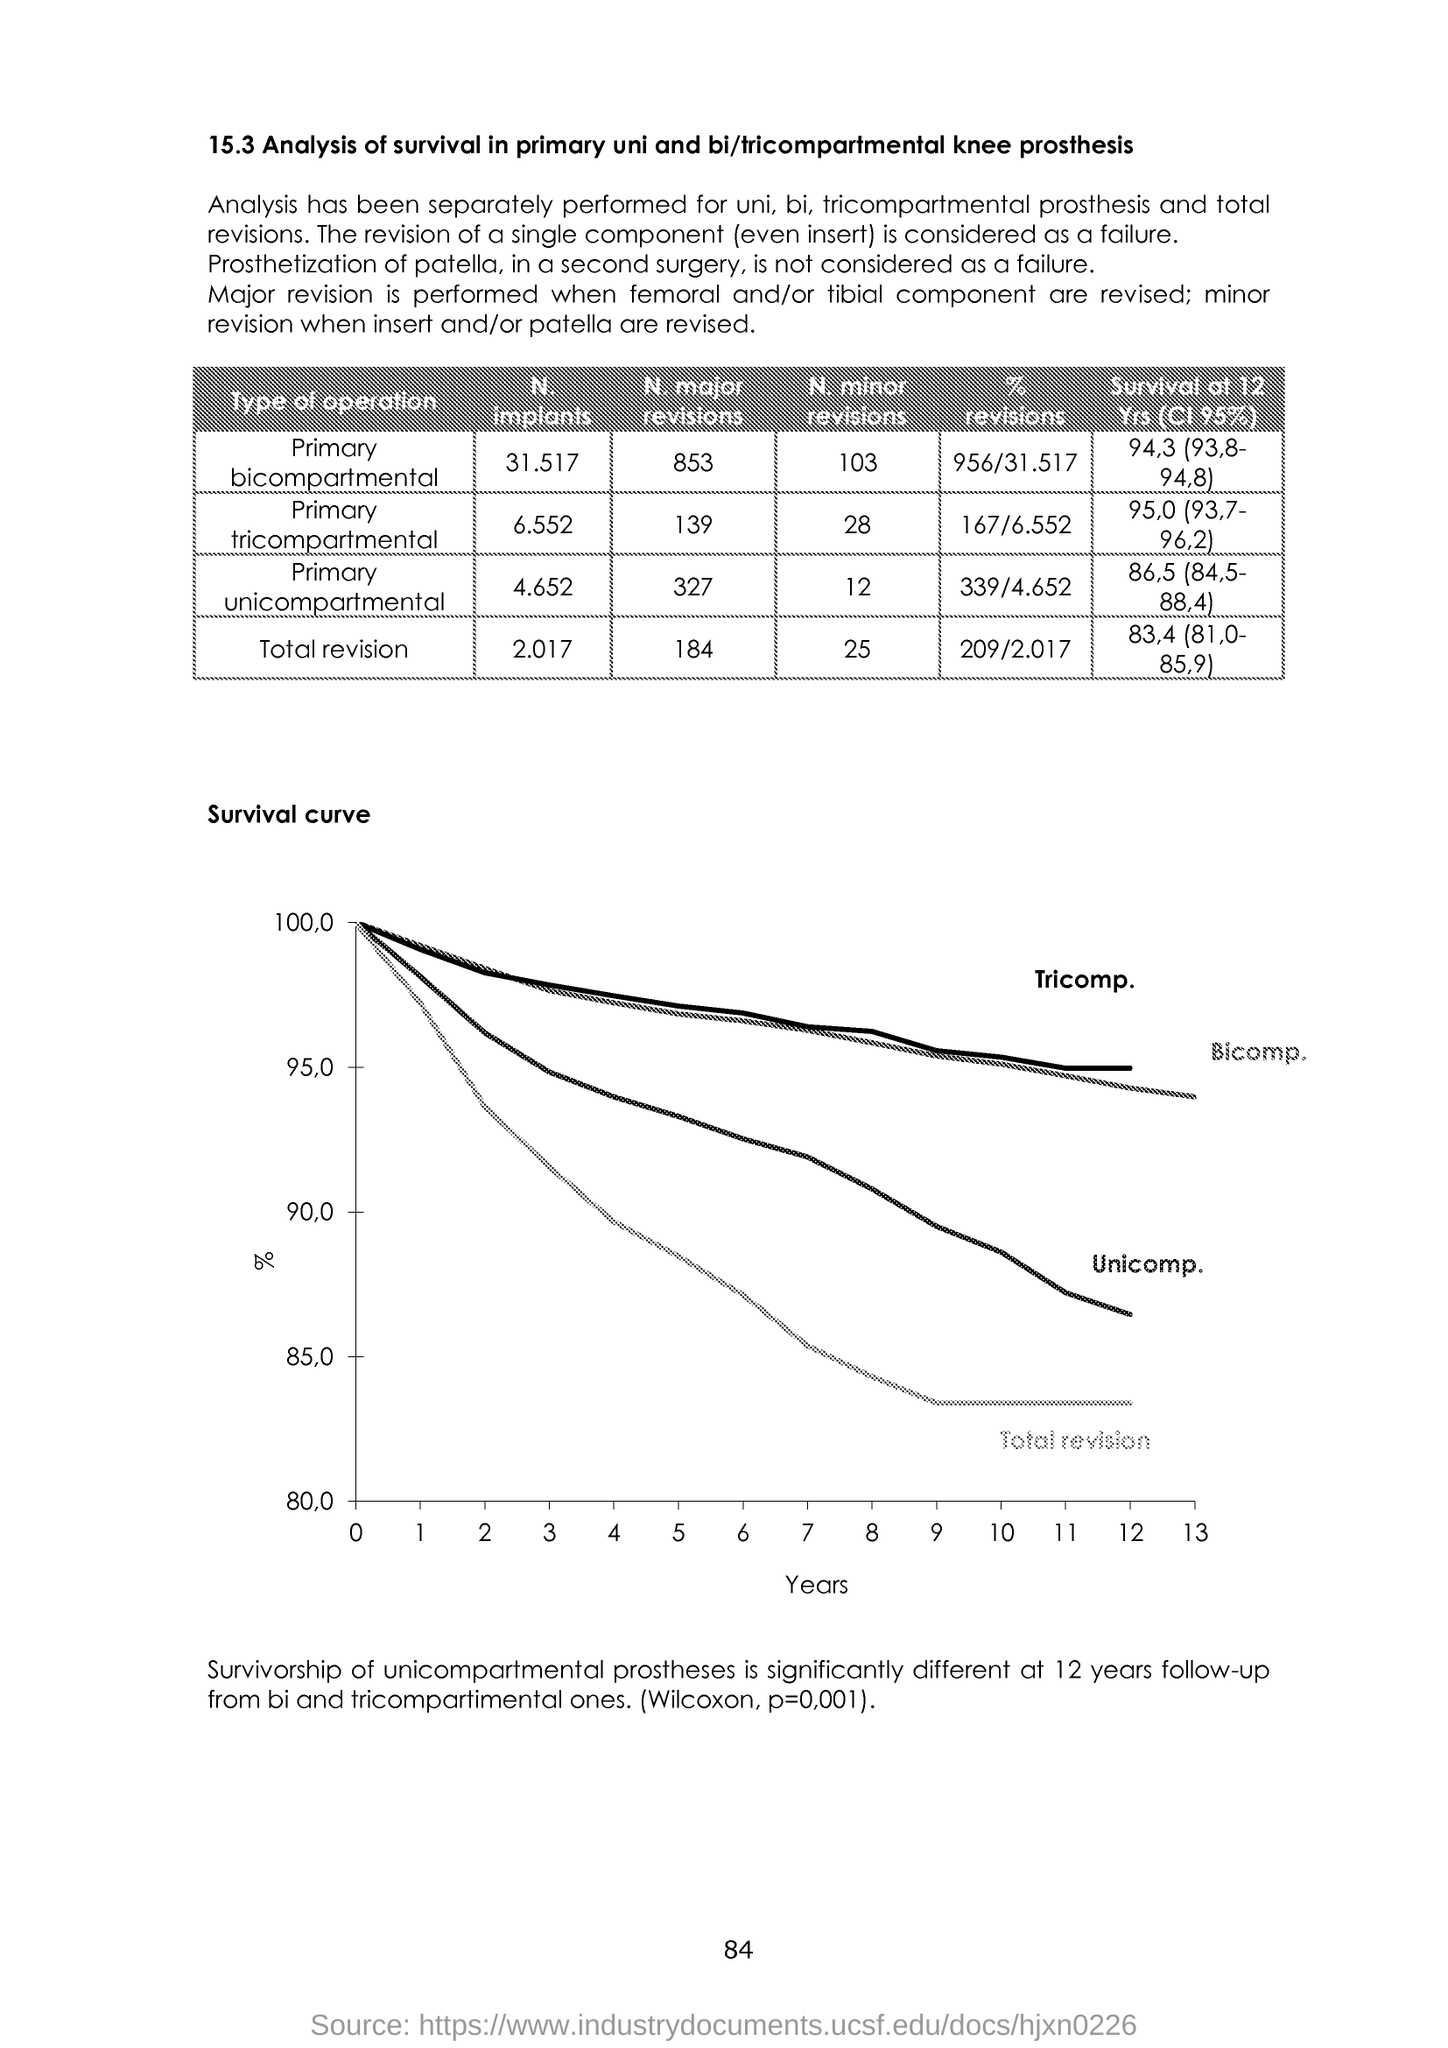What does the survival curve tell us? The survival curve shows the percentage of knee prostheses that have not required revision surgery over time. Each line represents a different type of prosthesis – unicomparmental (Uni.), bicompartmental (Bi.), and tricompartmental (Tricomp.) – with the space above each line reflecting the proportion of prostheses still in use at each year mark. A steeper decline indicates a higher rate of revision surgeries. 